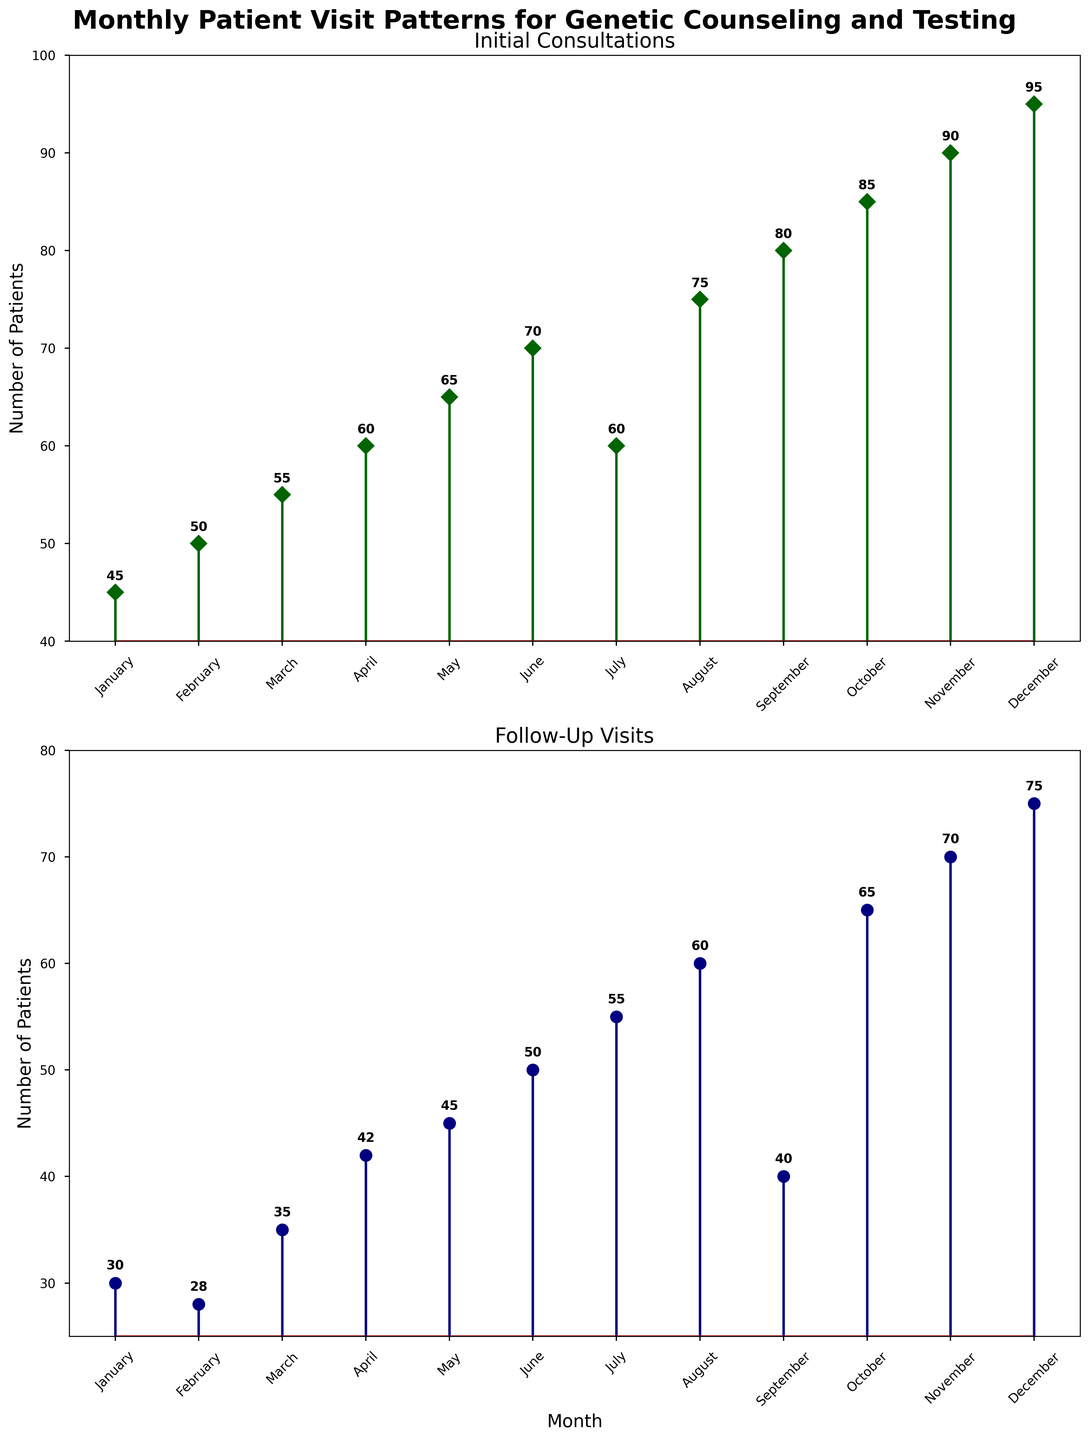How many initial consultations were there in July? The plot shows the number of initial consultations for each month. In July, the stem line reaches up to 60.
Answer: 60 What is the difference in the number of follow-up visits between January and December? January has 30 follow-up visits, and December has 75 follow-up visits. The difference is 75 - 30.
Answer: 45 Which month had the highest number of initial consultations? The plot shows the highest stem line for initial consultations in December, reaching 95.
Answer: December During which month did the follow-up visits have the lowest number? The plot shows that January has the lowest stem line for follow-up visits, reaching 30.
Answer: January On average, how many initial consultations were recorded from January to June? The values from January to June are 45, 50, 55, 60, 65, and 70. Calculate the average by summing them (45+50+55+60+65+70) = 345, then divide by 6.
Answer: 57.5 Compare the number of initial consultations and follow-up visits in October. Which one had more? Initial consultations in October are 85, and follow-up visits are 65. Initial consultations are greater than follow-up visits.
Answer: Initial consultations What is the total number of follow-up visits recorded in February, March, and April? Follow-up visits for February, March, and April are 28, 35, and 42. The total is 28 + 35 + 42.
Answer: 105 How many months had 75 or more initial consultations? The months with initial consultations of 75 or more are August, September, October, November, and December. So there are 5 such months.
Answer: 5 Is there a month where the number of follow-up visits is exactly 50? Yes, in June, the follow-up visits are exactly 50 as indicated by the stem line.
Answer: June In which month does the number of follow-up visits show a significant drop compared to the previous month? In September, the follow-up visits drop significantly to 40 from 60 in August. This is a drop of 20 visits.
Answer: September 